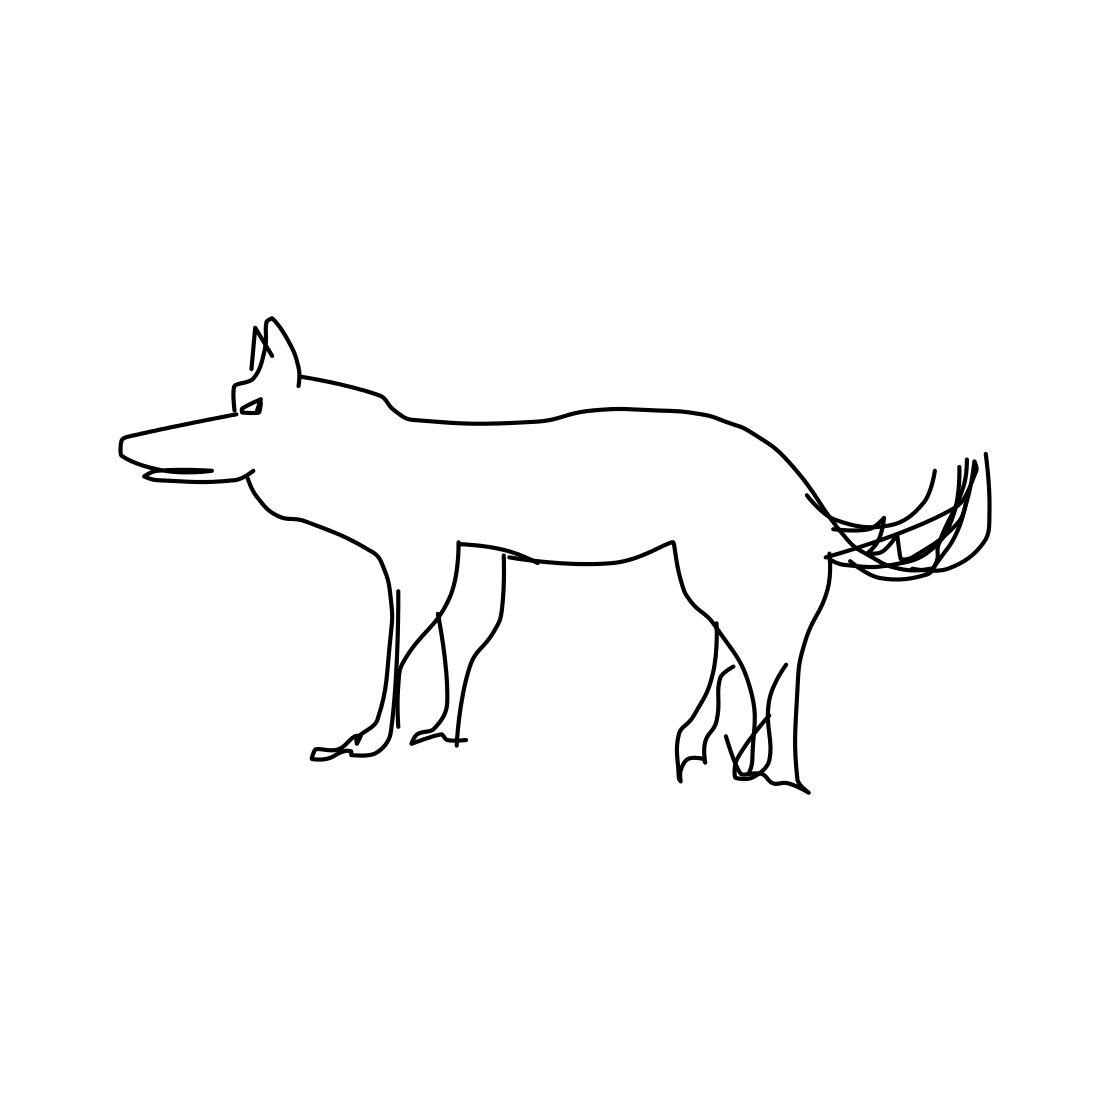What kind of artistic style is used in this drawing of the dog? The drawing of the dog utilizes a minimalist line art style, which is characterized by the use of clean and unadorned lines to define the shape of the subject without any intricate detailing or shading. Does this image suggest any particular emotion or mood? Line drawings like this one often invite personal interpretation, leaving the mood or emotion conveyed up to the viewer. The lack of expressive details makes it neutral, yet its simplicity can also elicit a sense of calm and tranquility. 